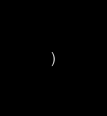Convert code to text. <code><loc_0><loc_0><loc_500><loc_500><_SQL_>)
</code> 